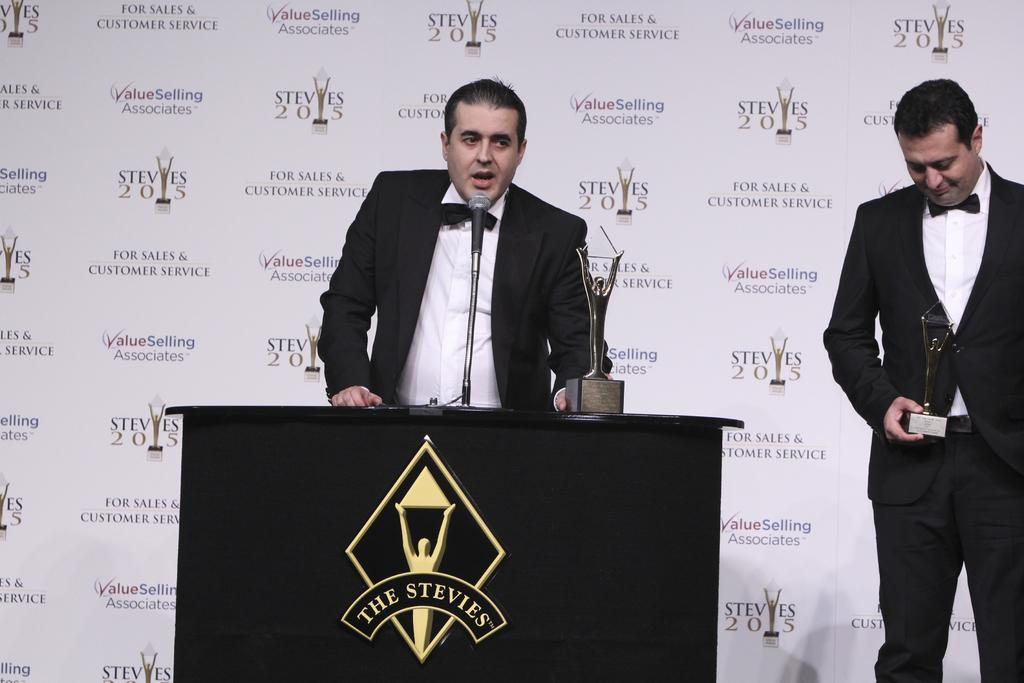How many people are in the image? There are two guys in the image. What are the guys doing in the image? The guys have received awards, and one of them is talking in front of a microphone. What can be seen in the background of the image? There is a poster in the background of the image. What is written on the poster? The poster has "STEVIES 2015" written on it. Can you see a bear in the image? No, there is no bear present in the image. Is there a sink visible in the image? No, there is no sink visible in the image. 